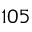Convert formula to latex. <formula><loc_0><loc_0><loc_500><loc_500>1 0 5</formula> 